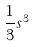<formula> <loc_0><loc_0><loc_500><loc_500>\frac { 1 } { 3 } s ^ { 3 }</formula> 